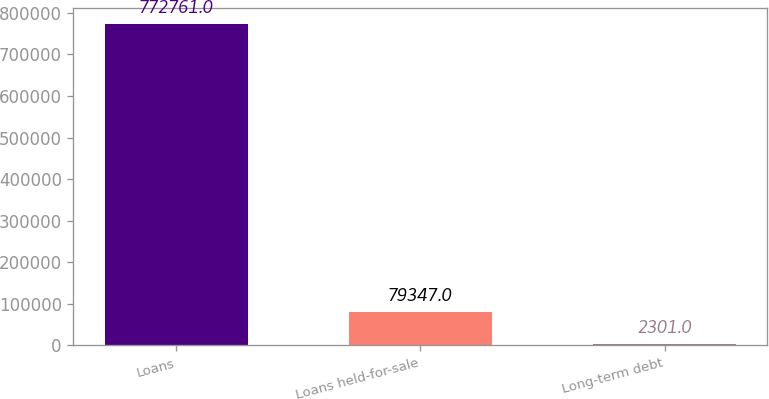<chart> <loc_0><loc_0><loc_500><loc_500><bar_chart><fcel>Loans<fcel>Loans held-for-sale<fcel>Long-term debt<nl><fcel>772761<fcel>79347<fcel>2301<nl></chart> 